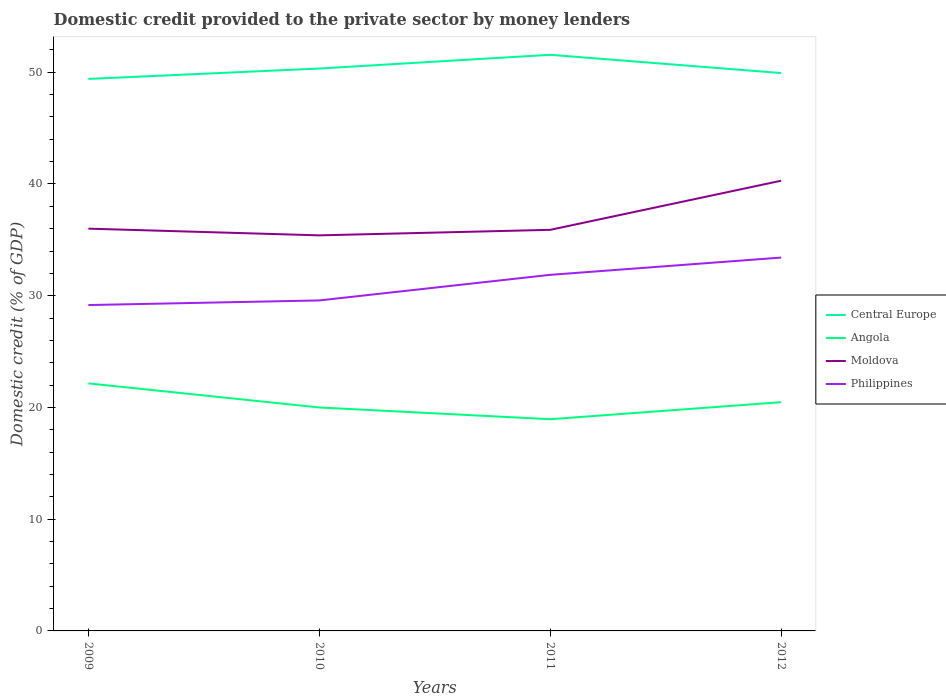How many different coloured lines are there?
Your response must be concise. 4. Across all years, what is the maximum domestic credit provided to the private sector by money lenders in Central Europe?
Give a very brief answer. 49.4. In which year was the domestic credit provided to the private sector by money lenders in Angola maximum?
Provide a short and direct response. 2011. What is the total domestic credit provided to the private sector by money lenders in Angola in the graph?
Make the answer very short. -1.53. What is the difference between the highest and the second highest domestic credit provided to the private sector by money lenders in Angola?
Ensure brevity in your answer.  3.21. Is the domestic credit provided to the private sector by money lenders in Angola strictly greater than the domestic credit provided to the private sector by money lenders in Central Europe over the years?
Offer a terse response. Yes. How many years are there in the graph?
Provide a short and direct response. 4. Are the values on the major ticks of Y-axis written in scientific E-notation?
Offer a very short reply. No. Does the graph contain grids?
Give a very brief answer. No. Where does the legend appear in the graph?
Your response must be concise. Center right. How are the legend labels stacked?
Keep it short and to the point. Vertical. What is the title of the graph?
Offer a terse response. Domestic credit provided to the private sector by money lenders. What is the label or title of the Y-axis?
Offer a terse response. Domestic credit (% of GDP). What is the Domestic credit (% of GDP) of Central Europe in 2009?
Offer a very short reply. 49.4. What is the Domestic credit (% of GDP) of Angola in 2009?
Your response must be concise. 22.15. What is the Domestic credit (% of GDP) in Moldova in 2009?
Offer a terse response. 36. What is the Domestic credit (% of GDP) of Philippines in 2009?
Give a very brief answer. 29.16. What is the Domestic credit (% of GDP) in Central Europe in 2010?
Make the answer very short. 50.33. What is the Domestic credit (% of GDP) in Angola in 2010?
Keep it short and to the point. 20. What is the Domestic credit (% of GDP) of Moldova in 2010?
Make the answer very short. 35.4. What is the Domestic credit (% of GDP) in Philippines in 2010?
Offer a very short reply. 29.58. What is the Domestic credit (% of GDP) of Central Europe in 2011?
Make the answer very short. 51.56. What is the Domestic credit (% of GDP) in Angola in 2011?
Offer a very short reply. 18.95. What is the Domestic credit (% of GDP) of Moldova in 2011?
Make the answer very short. 35.9. What is the Domestic credit (% of GDP) in Philippines in 2011?
Your answer should be compact. 31.87. What is the Domestic credit (% of GDP) in Central Europe in 2012?
Make the answer very short. 49.93. What is the Domestic credit (% of GDP) of Angola in 2012?
Keep it short and to the point. 20.47. What is the Domestic credit (% of GDP) of Moldova in 2012?
Provide a short and direct response. 40.29. What is the Domestic credit (% of GDP) in Philippines in 2012?
Your answer should be very brief. 33.41. Across all years, what is the maximum Domestic credit (% of GDP) of Central Europe?
Provide a succinct answer. 51.56. Across all years, what is the maximum Domestic credit (% of GDP) of Angola?
Your answer should be very brief. 22.15. Across all years, what is the maximum Domestic credit (% of GDP) in Moldova?
Offer a very short reply. 40.29. Across all years, what is the maximum Domestic credit (% of GDP) in Philippines?
Give a very brief answer. 33.41. Across all years, what is the minimum Domestic credit (% of GDP) of Central Europe?
Your response must be concise. 49.4. Across all years, what is the minimum Domestic credit (% of GDP) of Angola?
Give a very brief answer. 18.95. Across all years, what is the minimum Domestic credit (% of GDP) in Moldova?
Provide a short and direct response. 35.4. Across all years, what is the minimum Domestic credit (% of GDP) in Philippines?
Offer a terse response. 29.16. What is the total Domestic credit (% of GDP) in Central Europe in the graph?
Provide a succinct answer. 201.22. What is the total Domestic credit (% of GDP) in Angola in the graph?
Give a very brief answer. 81.57. What is the total Domestic credit (% of GDP) in Moldova in the graph?
Keep it short and to the point. 147.59. What is the total Domestic credit (% of GDP) of Philippines in the graph?
Give a very brief answer. 124.02. What is the difference between the Domestic credit (% of GDP) of Central Europe in 2009 and that in 2010?
Offer a terse response. -0.93. What is the difference between the Domestic credit (% of GDP) of Angola in 2009 and that in 2010?
Offer a terse response. 2.16. What is the difference between the Domestic credit (% of GDP) of Moldova in 2009 and that in 2010?
Provide a succinct answer. 0.6. What is the difference between the Domestic credit (% of GDP) in Philippines in 2009 and that in 2010?
Your response must be concise. -0.42. What is the difference between the Domestic credit (% of GDP) of Central Europe in 2009 and that in 2011?
Offer a very short reply. -2.16. What is the difference between the Domestic credit (% of GDP) in Angola in 2009 and that in 2011?
Give a very brief answer. 3.21. What is the difference between the Domestic credit (% of GDP) in Moldova in 2009 and that in 2011?
Ensure brevity in your answer.  0.11. What is the difference between the Domestic credit (% of GDP) of Philippines in 2009 and that in 2011?
Your answer should be very brief. -2.71. What is the difference between the Domestic credit (% of GDP) in Central Europe in 2009 and that in 2012?
Provide a succinct answer. -0.53. What is the difference between the Domestic credit (% of GDP) in Angola in 2009 and that in 2012?
Give a very brief answer. 1.68. What is the difference between the Domestic credit (% of GDP) in Moldova in 2009 and that in 2012?
Your answer should be compact. -4.29. What is the difference between the Domestic credit (% of GDP) in Philippines in 2009 and that in 2012?
Your answer should be very brief. -4.25. What is the difference between the Domestic credit (% of GDP) of Central Europe in 2010 and that in 2011?
Your answer should be compact. -1.23. What is the difference between the Domestic credit (% of GDP) in Angola in 2010 and that in 2011?
Keep it short and to the point. 1.05. What is the difference between the Domestic credit (% of GDP) in Moldova in 2010 and that in 2011?
Provide a succinct answer. -0.5. What is the difference between the Domestic credit (% of GDP) of Philippines in 2010 and that in 2011?
Ensure brevity in your answer.  -2.29. What is the difference between the Domestic credit (% of GDP) of Central Europe in 2010 and that in 2012?
Keep it short and to the point. 0.4. What is the difference between the Domestic credit (% of GDP) of Angola in 2010 and that in 2012?
Offer a very short reply. -0.47. What is the difference between the Domestic credit (% of GDP) of Moldova in 2010 and that in 2012?
Your response must be concise. -4.89. What is the difference between the Domestic credit (% of GDP) of Philippines in 2010 and that in 2012?
Make the answer very short. -3.84. What is the difference between the Domestic credit (% of GDP) in Central Europe in 2011 and that in 2012?
Your response must be concise. 1.63. What is the difference between the Domestic credit (% of GDP) in Angola in 2011 and that in 2012?
Give a very brief answer. -1.52. What is the difference between the Domestic credit (% of GDP) of Moldova in 2011 and that in 2012?
Ensure brevity in your answer.  -4.4. What is the difference between the Domestic credit (% of GDP) in Philippines in 2011 and that in 2012?
Offer a very short reply. -1.55. What is the difference between the Domestic credit (% of GDP) of Central Europe in 2009 and the Domestic credit (% of GDP) of Angola in 2010?
Your response must be concise. 29.4. What is the difference between the Domestic credit (% of GDP) in Central Europe in 2009 and the Domestic credit (% of GDP) in Moldova in 2010?
Keep it short and to the point. 14. What is the difference between the Domestic credit (% of GDP) of Central Europe in 2009 and the Domestic credit (% of GDP) of Philippines in 2010?
Your answer should be very brief. 19.82. What is the difference between the Domestic credit (% of GDP) in Angola in 2009 and the Domestic credit (% of GDP) in Moldova in 2010?
Provide a short and direct response. -13.25. What is the difference between the Domestic credit (% of GDP) of Angola in 2009 and the Domestic credit (% of GDP) of Philippines in 2010?
Keep it short and to the point. -7.42. What is the difference between the Domestic credit (% of GDP) of Moldova in 2009 and the Domestic credit (% of GDP) of Philippines in 2010?
Your response must be concise. 6.42. What is the difference between the Domestic credit (% of GDP) of Central Europe in 2009 and the Domestic credit (% of GDP) of Angola in 2011?
Your answer should be compact. 30.46. What is the difference between the Domestic credit (% of GDP) of Central Europe in 2009 and the Domestic credit (% of GDP) of Moldova in 2011?
Your response must be concise. 13.51. What is the difference between the Domestic credit (% of GDP) in Central Europe in 2009 and the Domestic credit (% of GDP) in Philippines in 2011?
Ensure brevity in your answer.  17.53. What is the difference between the Domestic credit (% of GDP) in Angola in 2009 and the Domestic credit (% of GDP) in Moldova in 2011?
Ensure brevity in your answer.  -13.74. What is the difference between the Domestic credit (% of GDP) of Angola in 2009 and the Domestic credit (% of GDP) of Philippines in 2011?
Ensure brevity in your answer.  -9.71. What is the difference between the Domestic credit (% of GDP) in Moldova in 2009 and the Domestic credit (% of GDP) in Philippines in 2011?
Give a very brief answer. 4.13. What is the difference between the Domestic credit (% of GDP) of Central Europe in 2009 and the Domestic credit (% of GDP) of Angola in 2012?
Your response must be concise. 28.93. What is the difference between the Domestic credit (% of GDP) in Central Europe in 2009 and the Domestic credit (% of GDP) in Moldova in 2012?
Provide a short and direct response. 9.11. What is the difference between the Domestic credit (% of GDP) of Central Europe in 2009 and the Domestic credit (% of GDP) of Philippines in 2012?
Your response must be concise. 15.99. What is the difference between the Domestic credit (% of GDP) in Angola in 2009 and the Domestic credit (% of GDP) in Moldova in 2012?
Keep it short and to the point. -18.14. What is the difference between the Domestic credit (% of GDP) in Angola in 2009 and the Domestic credit (% of GDP) in Philippines in 2012?
Give a very brief answer. -11.26. What is the difference between the Domestic credit (% of GDP) of Moldova in 2009 and the Domestic credit (% of GDP) of Philippines in 2012?
Your answer should be compact. 2.59. What is the difference between the Domestic credit (% of GDP) in Central Europe in 2010 and the Domestic credit (% of GDP) in Angola in 2011?
Keep it short and to the point. 31.39. What is the difference between the Domestic credit (% of GDP) in Central Europe in 2010 and the Domestic credit (% of GDP) in Moldova in 2011?
Your answer should be very brief. 14.44. What is the difference between the Domestic credit (% of GDP) in Central Europe in 2010 and the Domestic credit (% of GDP) in Philippines in 2011?
Offer a very short reply. 18.46. What is the difference between the Domestic credit (% of GDP) of Angola in 2010 and the Domestic credit (% of GDP) of Moldova in 2011?
Give a very brief answer. -15.9. What is the difference between the Domestic credit (% of GDP) of Angola in 2010 and the Domestic credit (% of GDP) of Philippines in 2011?
Provide a succinct answer. -11.87. What is the difference between the Domestic credit (% of GDP) in Moldova in 2010 and the Domestic credit (% of GDP) in Philippines in 2011?
Your answer should be very brief. 3.53. What is the difference between the Domestic credit (% of GDP) of Central Europe in 2010 and the Domestic credit (% of GDP) of Angola in 2012?
Your response must be concise. 29.86. What is the difference between the Domestic credit (% of GDP) of Central Europe in 2010 and the Domestic credit (% of GDP) of Moldova in 2012?
Keep it short and to the point. 10.04. What is the difference between the Domestic credit (% of GDP) of Central Europe in 2010 and the Domestic credit (% of GDP) of Philippines in 2012?
Make the answer very short. 16.92. What is the difference between the Domestic credit (% of GDP) in Angola in 2010 and the Domestic credit (% of GDP) in Moldova in 2012?
Give a very brief answer. -20.29. What is the difference between the Domestic credit (% of GDP) in Angola in 2010 and the Domestic credit (% of GDP) in Philippines in 2012?
Keep it short and to the point. -13.42. What is the difference between the Domestic credit (% of GDP) in Moldova in 2010 and the Domestic credit (% of GDP) in Philippines in 2012?
Keep it short and to the point. 1.99. What is the difference between the Domestic credit (% of GDP) of Central Europe in 2011 and the Domestic credit (% of GDP) of Angola in 2012?
Offer a very short reply. 31.09. What is the difference between the Domestic credit (% of GDP) of Central Europe in 2011 and the Domestic credit (% of GDP) of Moldova in 2012?
Make the answer very short. 11.27. What is the difference between the Domestic credit (% of GDP) in Central Europe in 2011 and the Domestic credit (% of GDP) in Philippines in 2012?
Make the answer very short. 18.15. What is the difference between the Domestic credit (% of GDP) in Angola in 2011 and the Domestic credit (% of GDP) in Moldova in 2012?
Keep it short and to the point. -21.35. What is the difference between the Domestic credit (% of GDP) of Angola in 2011 and the Domestic credit (% of GDP) of Philippines in 2012?
Your answer should be very brief. -14.47. What is the difference between the Domestic credit (% of GDP) of Moldova in 2011 and the Domestic credit (% of GDP) of Philippines in 2012?
Offer a very short reply. 2.48. What is the average Domestic credit (% of GDP) of Central Europe per year?
Offer a terse response. 50.31. What is the average Domestic credit (% of GDP) in Angola per year?
Provide a succinct answer. 20.39. What is the average Domestic credit (% of GDP) of Moldova per year?
Your response must be concise. 36.9. What is the average Domestic credit (% of GDP) in Philippines per year?
Your response must be concise. 31.01. In the year 2009, what is the difference between the Domestic credit (% of GDP) of Central Europe and Domestic credit (% of GDP) of Angola?
Offer a very short reply. 27.25. In the year 2009, what is the difference between the Domestic credit (% of GDP) in Central Europe and Domestic credit (% of GDP) in Moldova?
Offer a terse response. 13.4. In the year 2009, what is the difference between the Domestic credit (% of GDP) of Central Europe and Domestic credit (% of GDP) of Philippines?
Keep it short and to the point. 20.24. In the year 2009, what is the difference between the Domestic credit (% of GDP) in Angola and Domestic credit (% of GDP) in Moldova?
Keep it short and to the point. -13.85. In the year 2009, what is the difference between the Domestic credit (% of GDP) of Angola and Domestic credit (% of GDP) of Philippines?
Your response must be concise. -7.01. In the year 2009, what is the difference between the Domestic credit (% of GDP) in Moldova and Domestic credit (% of GDP) in Philippines?
Ensure brevity in your answer.  6.84. In the year 2010, what is the difference between the Domestic credit (% of GDP) in Central Europe and Domestic credit (% of GDP) in Angola?
Your response must be concise. 30.33. In the year 2010, what is the difference between the Domestic credit (% of GDP) of Central Europe and Domestic credit (% of GDP) of Moldova?
Offer a very short reply. 14.93. In the year 2010, what is the difference between the Domestic credit (% of GDP) in Central Europe and Domestic credit (% of GDP) in Philippines?
Ensure brevity in your answer.  20.75. In the year 2010, what is the difference between the Domestic credit (% of GDP) in Angola and Domestic credit (% of GDP) in Moldova?
Provide a succinct answer. -15.4. In the year 2010, what is the difference between the Domestic credit (% of GDP) in Angola and Domestic credit (% of GDP) in Philippines?
Keep it short and to the point. -9.58. In the year 2010, what is the difference between the Domestic credit (% of GDP) of Moldova and Domestic credit (% of GDP) of Philippines?
Offer a terse response. 5.82. In the year 2011, what is the difference between the Domestic credit (% of GDP) in Central Europe and Domestic credit (% of GDP) in Angola?
Offer a terse response. 32.62. In the year 2011, what is the difference between the Domestic credit (% of GDP) in Central Europe and Domestic credit (% of GDP) in Moldova?
Keep it short and to the point. 15.66. In the year 2011, what is the difference between the Domestic credit (% of GDP) of Central Europe and Domestic credit (% of GDP) of Philippines?
Your answer should be very brief. 19.69. In the year 2011, what is the difference between the Domestic credit (% of GDP) in Angola and Domestic credit (% of GDP) in Moldova?
Offer a very short reply. -16.95. In the year 2011, what is the difference between the Domestic credit (% of GDP) in Angola and Domestic credit (% of GDP) in Philippines?
Offer a terse response. -12.92. In the year 2011, what is the difference between the Domestic credit (% of GDP) of Moldova and Domestic credit (% of GDP) of Philippines?
Your answer should be compact. 4.03. In the year 2012, what is the difference between the Domestic credit (% of GDP) in Central Europe and Domestic credit (% of GDP) in Angola?
Offer a very short reply. 29.46. In the year 2012, what is the difference between the Domestic credit (% of GDP) of Central Europe and Domestic credit (% of GDP) of Moldova?
Keep it short and to the point. 9.64. In the year 2012, what is the difference between the Domestic credit (% of GDP) of Central Europe and Domestic credit (% of GDP) of Philippines?
Offer a very short reply. 16.51. In the year 2012, what is the difference between the Domestic credit (% of GDP) in Angola and Domestic credit (% of GDP) in Moldova?
Offer a terse response. -19.82. In the year 2012, what is the difference between the Domestic credit (% of GDP) of Angola and Domestic credit (% of GDP) of Philippines?
Give a very brief answer. -12.94. In the year 2012, what is the difference between the Domestic credit (% of GDP) in Moldova and Domestic credit (% of GDP) in Philippines?
Make the answer very short. 6.88. What is the ratio of the Domestic credit (% of GDP) in Central Europe in 2009 to that in 2010?
Offer a very short reply. 0.98. What is the ratio of the Domestic credit (% of GDP) of Angola in 2009 to that in 2010?
Your response must be concise. 1.11. What is the ratio of the Domestic credit (% of GDP) of Moldova in 2009 to that in 2010?
Provide a short and direct response. 1.02. What is the ratio of the Domestic credit (% of GDP) of Philippines in 2009 to that in 2010?
Your response must be concise. 0.99. What is the ratio of the Domestic credit (% of GDP) in Central Europe in 2009 to that in 2011?
Ensure brevity in your answer.  0.96. What is the ratio of the Domestic credit (% of GDP) in Angola in 2009 to that in 2011?
Offer a very short reply. 1.17. What is the ratio of the Domestic credit (% of GDP) in Philippines in 2009 to that in 2011?
Keep it short and to the point. 0.92. What is the ratio of the Domestic credit (% of GDP) in Central Europe in 2009 to that in 2012?
Offer a very short reply. 0.99. What is the ratio of the Domestic credit (% of GDP) in Angola in 2009 to that in 2012?
Your answer should be compact. 1.08. What is the ratio of the Domestic credit (% of GDP) in Moldova in 2009 to that in 2012?
Make the answer very short. 0.89. What is the ratio of the Domestic credit (% of GDP) of Philippines in 2009 to that in 2012?
Offer a very short reply. 0.87. What is the ratio of the Domestic credit (% of GDP) of Central Europe in 2010 to that in 2011?
Provide a short and direct response. 0.98. What is the ratio of the Domestic credit (% of GDP) of Angola in 2010 to that in 2011?
Offer a very short reply. 1.06. What is the ratio of the Domestic credit (% of GDP) in Moldova in 2010 to that in 2011?
Give a very brief answer. 0.99. What is the ratio of the Domestic credit (% of GDP) in Philippines in 2010 to that in 2011?
Offer a very short reply. 0.93. What is the ratio of the Domestic credit (% of GDP) of Angola in 2010 to that in 2012?
Your answer should be very brief. 0.98. What is the ratio of the Domestic credit (% of GDP) in Moldova in 2010 to that in 2012?
Your response must be concise. 0.88. What is the ratio of the Domestic credit (% of GDP) in Philippines in 2010 to that in 2012?
Ensure brevity in your answer.  0.89. What is the ratio of the Domestic credit (% of GDP) in Central Europe in 2011 to that in 2012?
Your answer should be compact. 1.03. What is the ratio of the Domestic credit (% of GDP) of Angola in 2011 to that in 2012?
Give a very brief answer. 0.93. What is the ratio of the Domestic credit (% of GDP) of Moldova in 2011 to that in 2012?
Give a very brief answer. 0.89. What is the ratio of the Domestic credit (% of GDP) of Philippines in 2011 to that in 2012?
Provide a short and direct response. 0.95. What is the difference between the highest and the second highest Domestic credit (% of GDP) in Central Europe?
Your answer should be very brief. 1.23. What is the difference between the highest and the second highest Domestic credit (% of GDP) of Angola?
Ensure brevity in your answer.  1.68. What is the difference between the highest and the second highest Domestic credit (% of GDP) in Moldova?
Ensure brevity in your answer.  4.29. What is the difference between the highest and the second highest Domestic credit (% of GDP) of Philippines?
Keep it short and to the point. 1.55. What is the difference between the highest and the lowest Domestic credit (% of GDP) in Central Europe?
Your answer should be compact. 2.16. What is the difference between the highest and the lowest Domestic credit (% of GDP) in Angola?
Provide a succinct answer. 3.21. What is the difference between the highest and the lowest Domestic credit (% of GDP) in Moldova?
Provide a succinct answer. 4.89. What is the difference between the highest and the lowest Domestic credit (% of GDP) in Philippines?
Give a very brief answer. 4.25. 